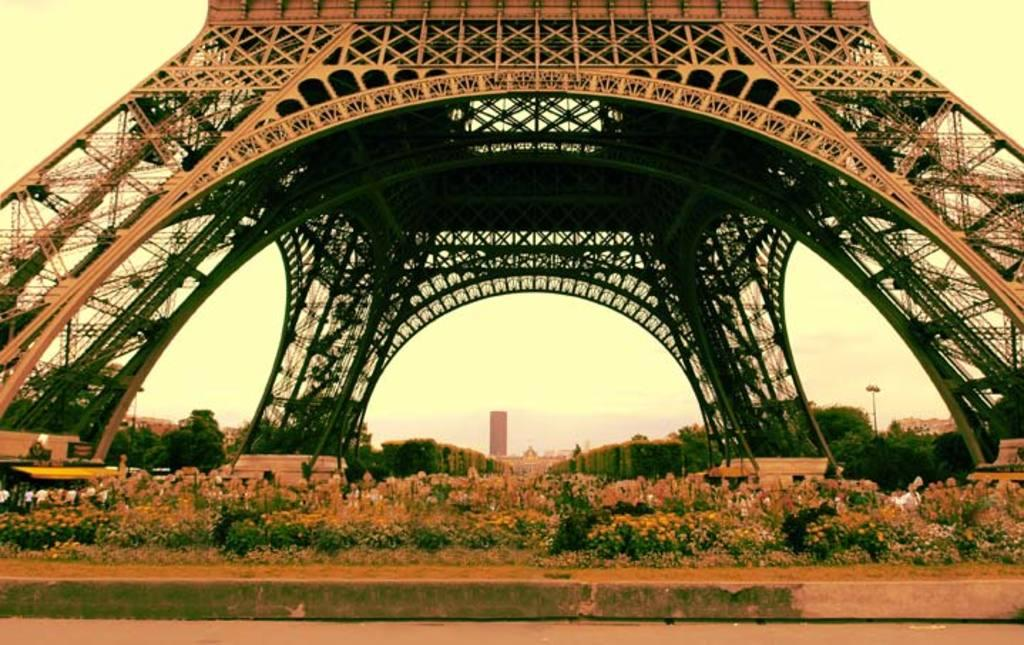What can be seen in the background of the image? The sky is visible in the image. What type of natural elements are present in the image? There are trees in the image. What type of man-made structures can be seen in the image? There is architecture in the image. What type of living organisms can be seen in the image? Plants are present in the image. What is the price of the knowledge depicted in the image? There is no depiction of knowledge or any price associated with it in the image. 